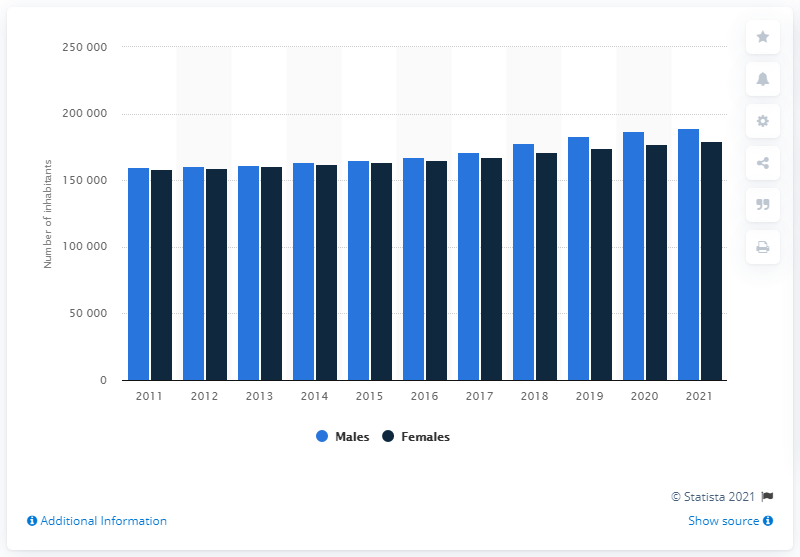Highlight a few significant elements in this photo. As of January 2021, the population of Iceland was 189,043. Between 2011 and 2021, there were a total of 179,749 females living in Iceland. 